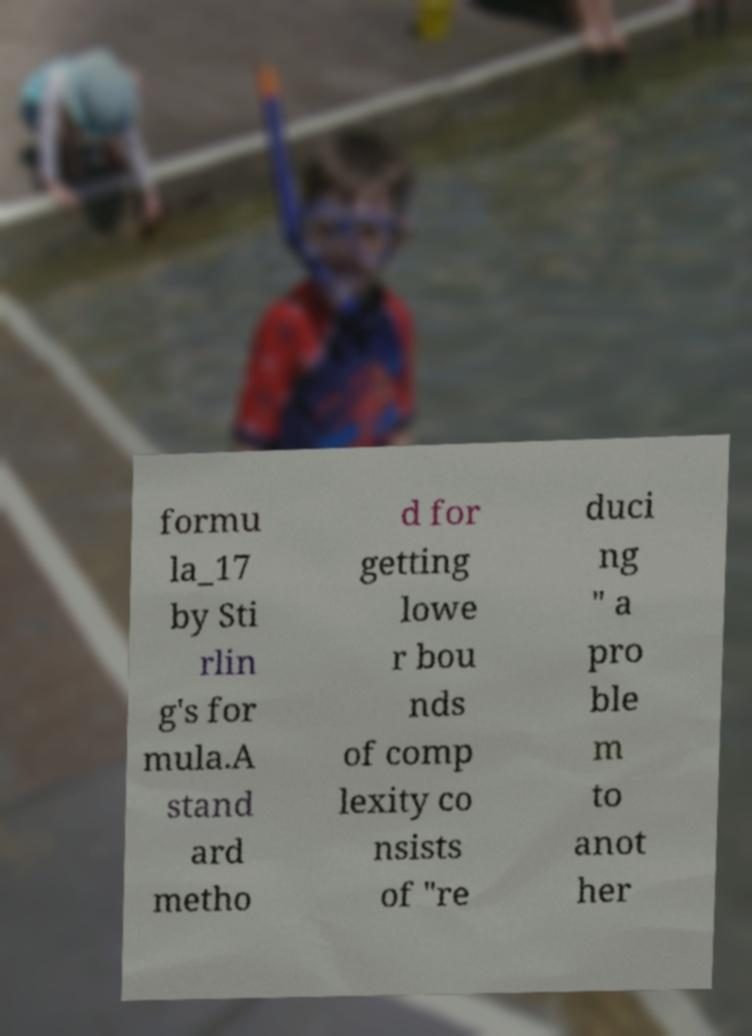Please read and relay the text visible in this image. What does it say? formu la_17 by Sti rlin g's for mula.A stand ard metho d for getting lowe r bou nds of comp lexity co nsists of "re duci ng " a pro ble m to anot her 